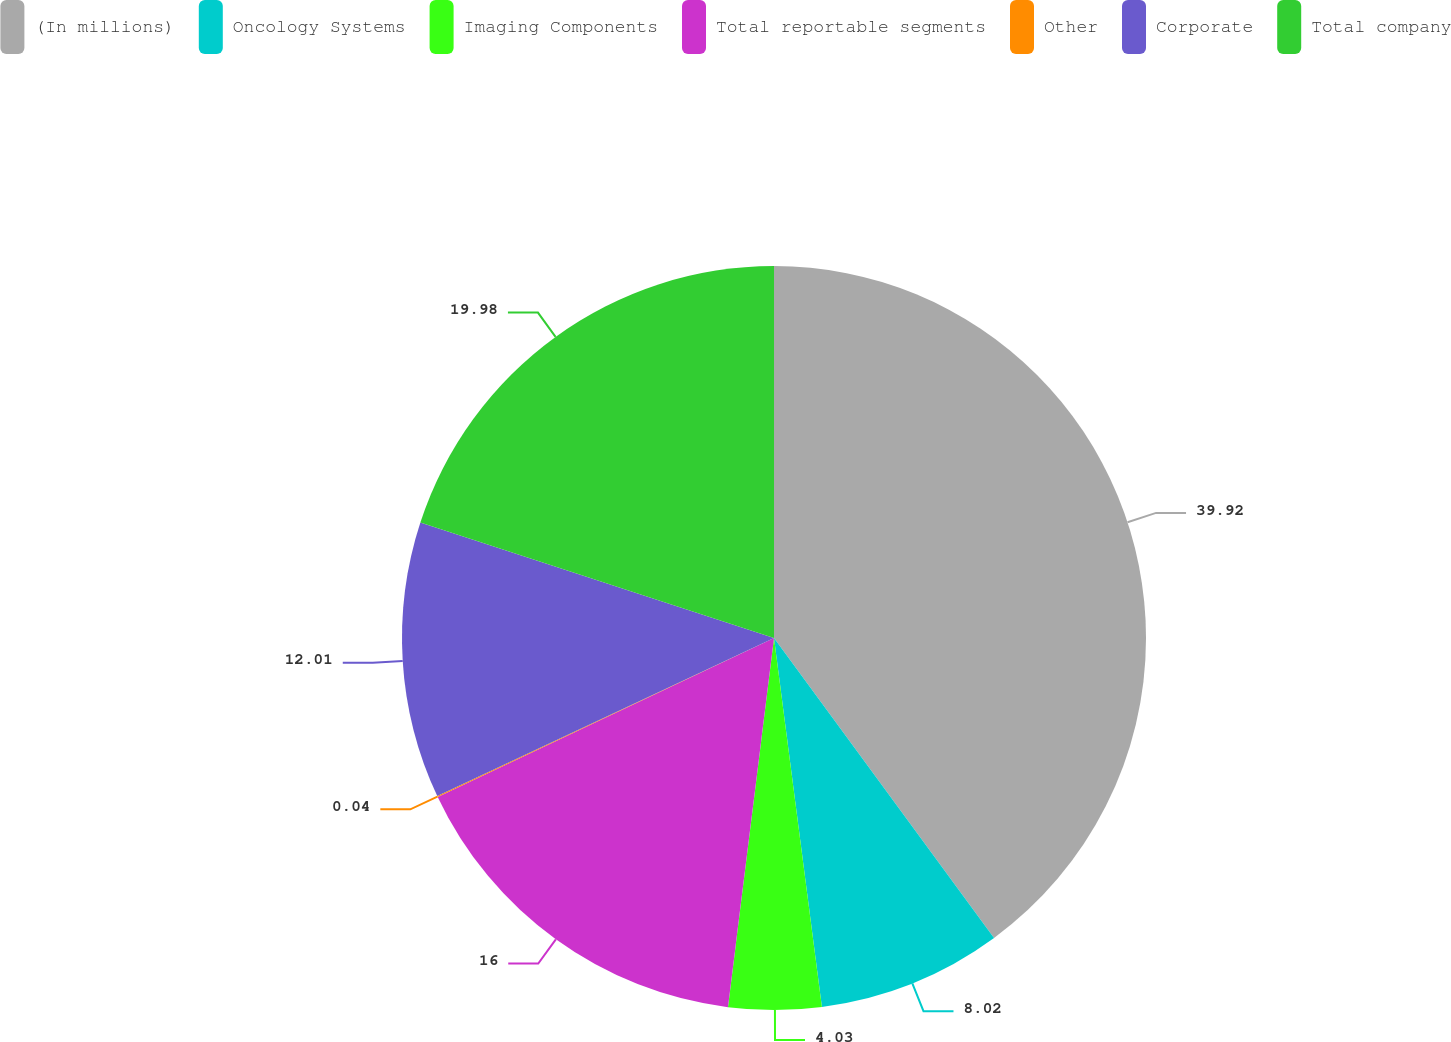Convert chart. <chart><loc_0><loc_0><loc_500><loc_500><pie_chart><fcel>(In millions)<fcel>Oncology Systems<fcel>Imaging Components<fcel>Total reportable segments<fcel>Other<fcel>Corporate<fcel>Total company<nl><fcel>39.93%<fcel>8.02%<fcel>4.03%<fcel>16.0%<fcel>0.04%<fcel>12.01%<fcel>19.98%<nl></chart> 